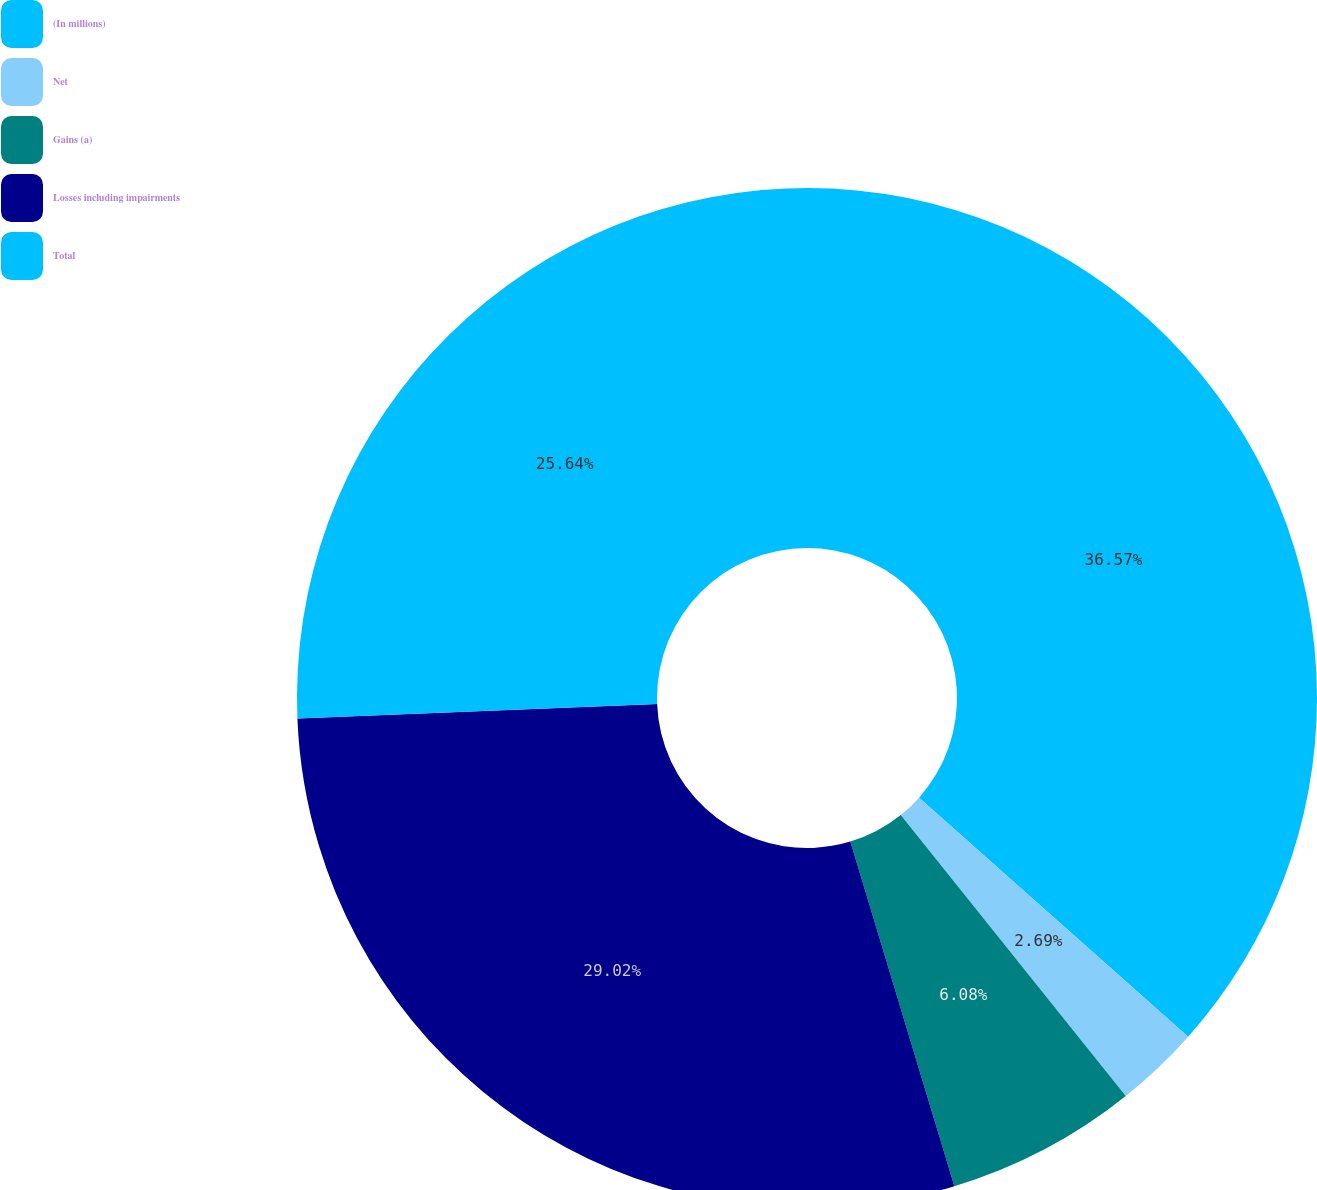Convert chart. <chart><loc_0><loc_0><loc_500><loc_500><pie_chart><fcel>(In millions)<fcel>Net<fcel>Gains (a)<fcel>Losses including impairments<fcel>Total<nl><fcel>36.56%<fcel>2.69%<fcel>6.08%<fcel>29.02%<fcel>25.64%<nl></chart> 